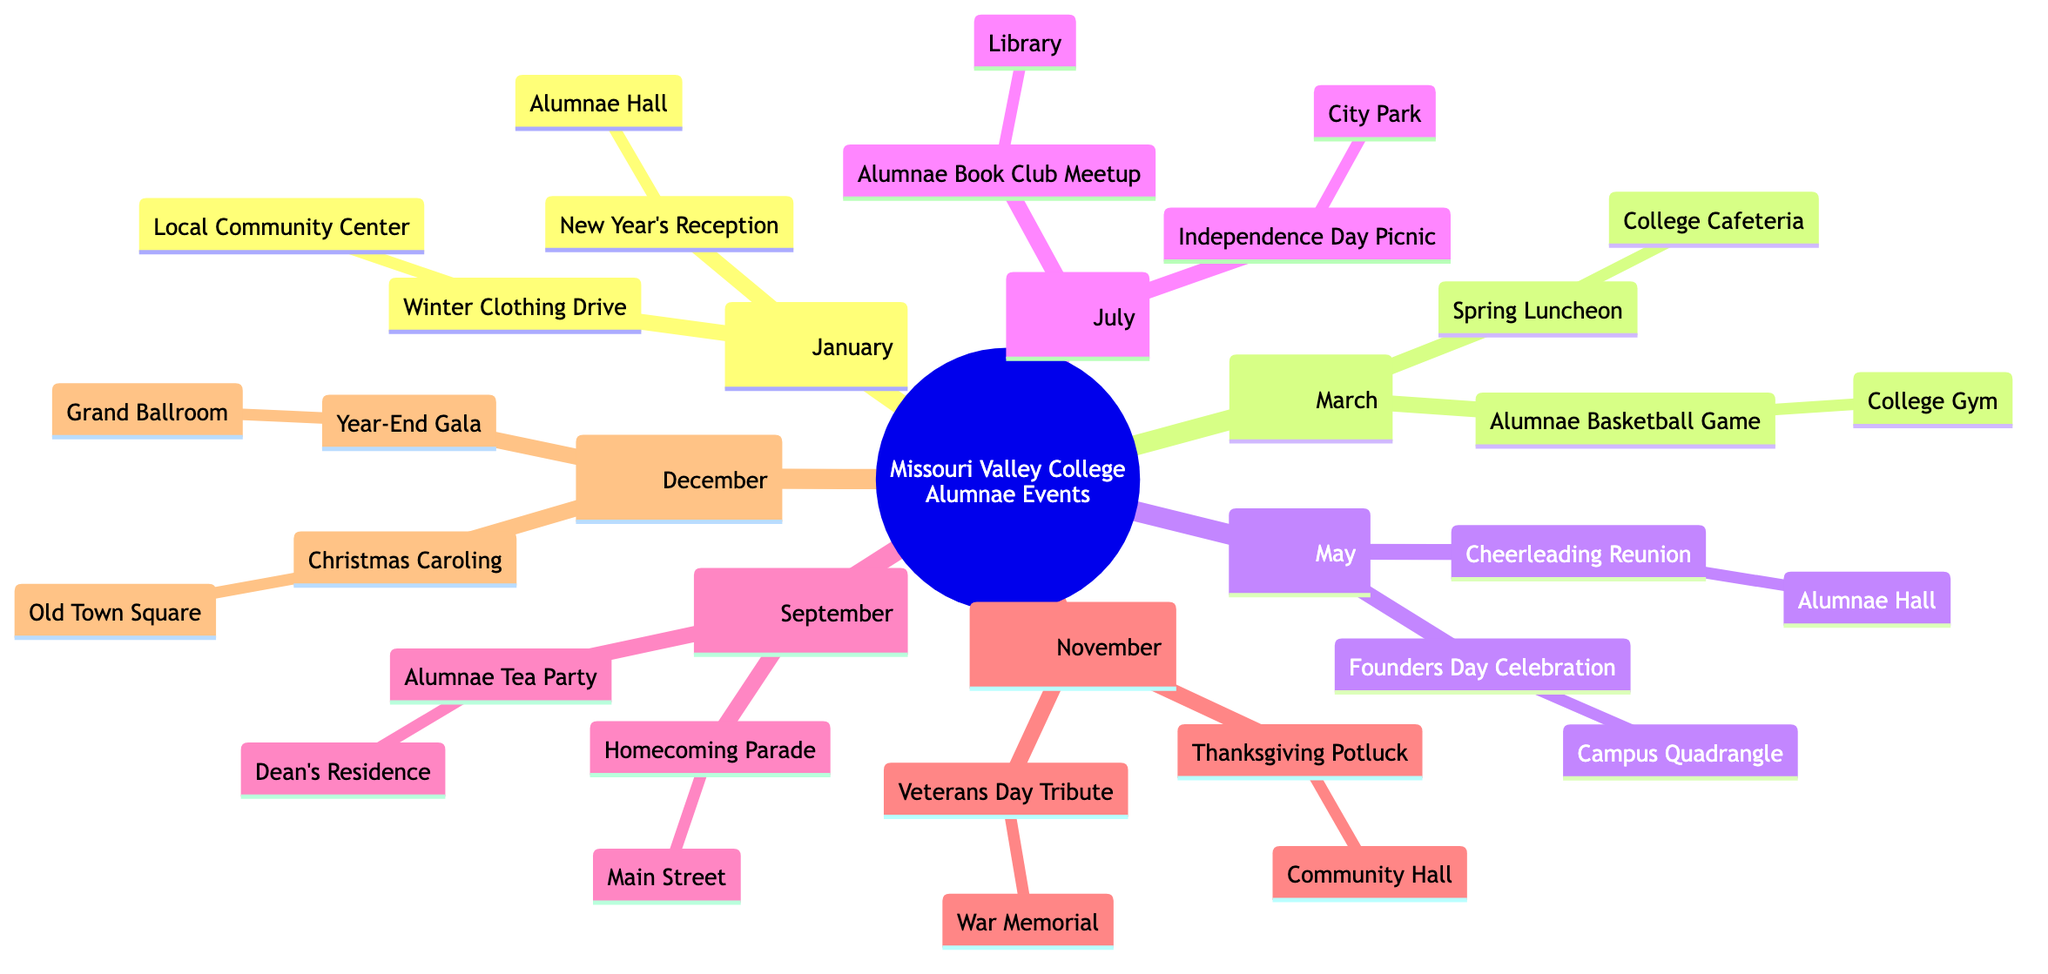What events are scheduled for May? In the diagram, under the month of May, the events listed are "Founders Day Celebration" and "Cheerleading Reunion".
Answer: Founders Day Celebration, Cheerleading Reunion How many events occur in November? In the month of November, there are two events listed: "Thanksgiving Potluck" and "Veterans Day Tribute". Therefore, the total number of events in November is two.
Answer: 2 Which event takes place in January at the Local Community Center? The event listed for January at the Local Community Center is "Winter Clothing Drive".
Answer: Winter Clothing Drive What are the locations for the events in July? In July, the events listed are "Independence Day Picnic" at City Park and "Alumnae Book Club Meetup" at the Library.
Answer: City Park, Library Which month has the "Homecoming Parade"? The "Homecoming Parade" is scheduled in the month of September, as indicated in the diagram.
Answer: September What is the total number of events in the diagram? The diagram includes a total of twelve events spread across six months. By counting each event from each month, we can ascertain that there are twelve events listed.
Answer: 12 Which is an event held at the Dean's Residence? The event held at the Dean's Residence is the "Alumnae Tea Party", as shown in the events for September.
Answer: Alumnae Tea Party Which two months feature events related to cheerleading? The two months that feature events related to cheerleading are May, which has "Cheerleading Reunion," and March, which has "Alumnae Basketball Game."
Answer: May, March What type of event is listed for December? In December, there are two events: "Christmas Caroling" and "Year-End Gala." Both events are social gatherings, making them festive occasions.
Answer: Christmas Caroling, Year-End Gala 